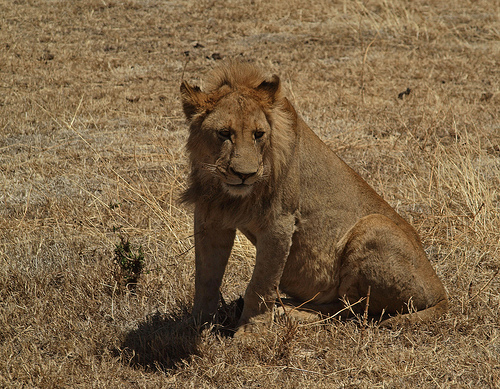<image>
Is there a lion in the ground? Yes. The lion is contained within or inside the ground, showing a containment relationship. 